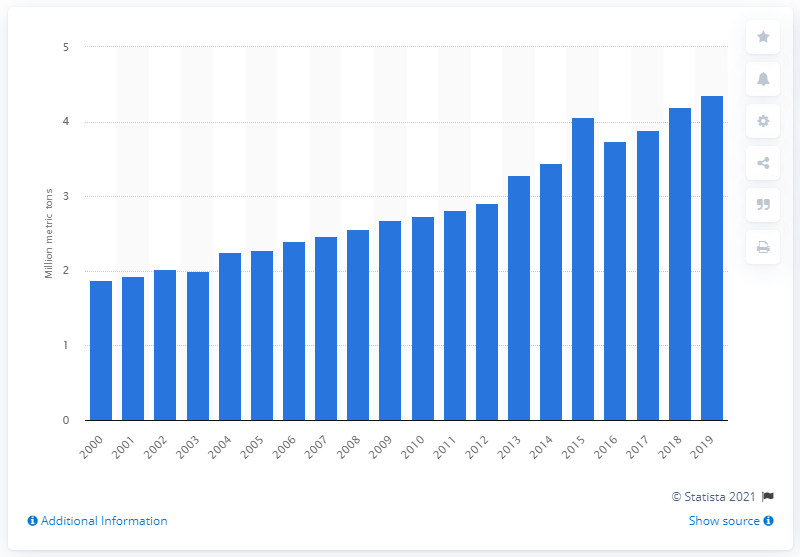Outline some significant characteristics in this image. In 2000, the global production volume of kiwi was 1.87 million metric tons. In 2019, the global production of kiwis was 4.35 million metric tons. 